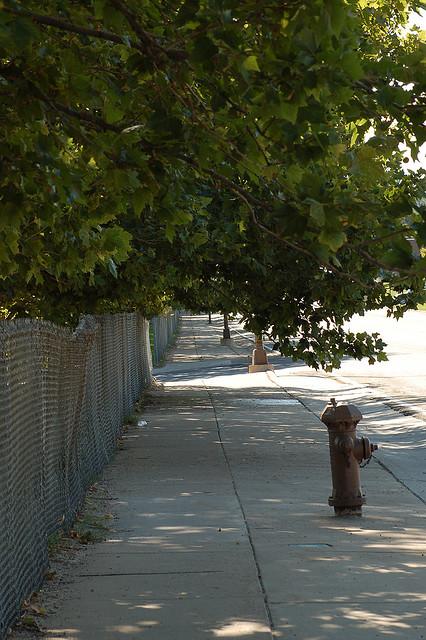Are there leaves on the trees? Yes, the trees are lush with green leaves, indicating that the photo was likely taken in the warmer seasons when trees are fully leafed out. 